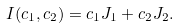Convert formula to latex. <formula><loc_0><loc_0><loc_500><loc_500>I ( c _ { 1 } , c _ { 2 } ) = c _ { 1 } J _ { 1 } + c _ { 2 } J _ { 2 } .</formula> 